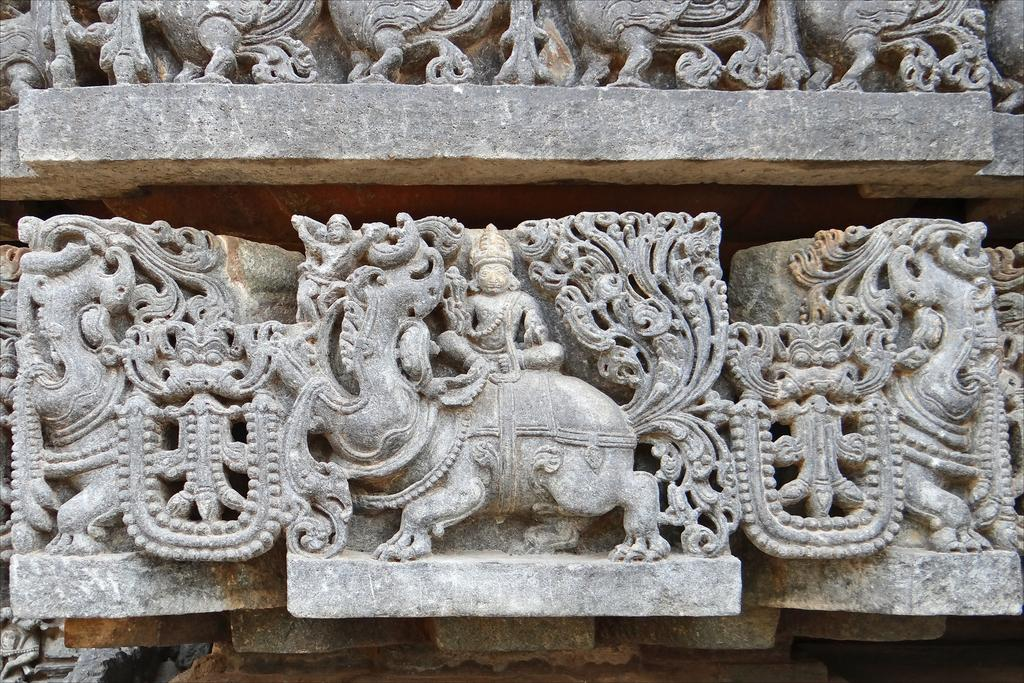What is present on the stone in the image? There are sculptures and designs on the stone in the image. Can you describe the sculptures on the stone? Unfortunately, the specific details of the sculptures cannot be determined from the provided facts. What type of designs are visible on the stone? The designs on the stone are not described in the provided facts, so we cannot determine their nature. How many pizzas are being served for dinner in the image? There is no mention of pizzas or dinner in the provided facts, so we cannot determine if they are present in the image. Can you describe the sheep grazing near the stone in the image? There is no mention of sheep in the provided facts, so we cannot determine if they are present in the image. 